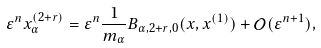<formula> <loc_0><loc_0><loc_500><loc_500>\varepsilon ^ { n } x _ { \alpha } ^ { ( 2 + r ) } = \varepsilon ^ { n } \frac { 1 } { m _ { \alpha } } B _ { \alpha , 2 + r , 0 } ( x , x ^ { ( 1 ) } ) + \mathcal { O } ( \varepsilon ^ { n + 1 } ) ,</formula> 